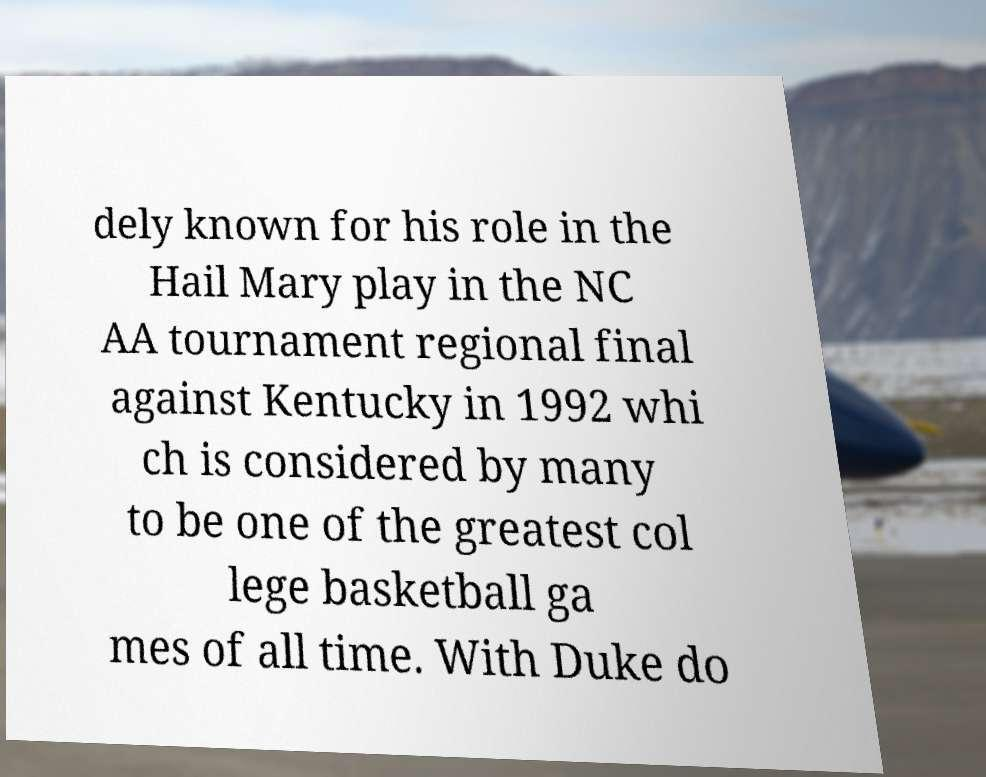Could you assist in decoding the text presented in this image and type it out clearly? dely known for his role in the Hail Mary play in the NC AA tournament regional final against Kentucky in 1992 whi ch is considered by many to be one of the greatest col lege basketball ga mes of all time. With Duke do 